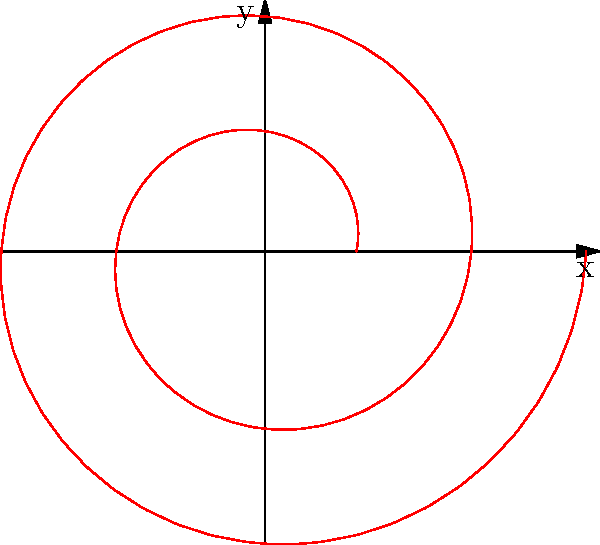In your latest Star Wars fan-fiction, you're describing a spaceship's spiral approach to a planet. The ship's path in polar coordinates is given by $r = 1 + 0.2\theta$, where $r$ is the distance from the planet's center (in planetary radii) and $\theta$ is the angle (in radians). If the ship completes two full revolutions around the planet, what is the final distance of the ship from the planet's center? To solve this problem, let's follow these steps:

1) First, we need to understand what two full revolutions mean in terms of $\theta$:
   - One full revolution is $2\pi$ radians
   - Two full revolutions is $4\pi$ radians

2) Now, we can use the given equation: $r = 1 + 0.2\theta$

3) We want to find $r$ when $\theta = 4\pi$:
   $r = 1 + 0.2(4\pi)$

4) Let's calculate:
   $r = 1 + 0.8\pi$
   $r = 1 + 2.513...$ (using $\pi \approx 3.14159$)
   $r \approx 3.513$

5) Therefore, after two full revolutions, the ship will be approximately 3.513 planetary radii away from the planet's center.
Answer: $3.513$ planetary radii 